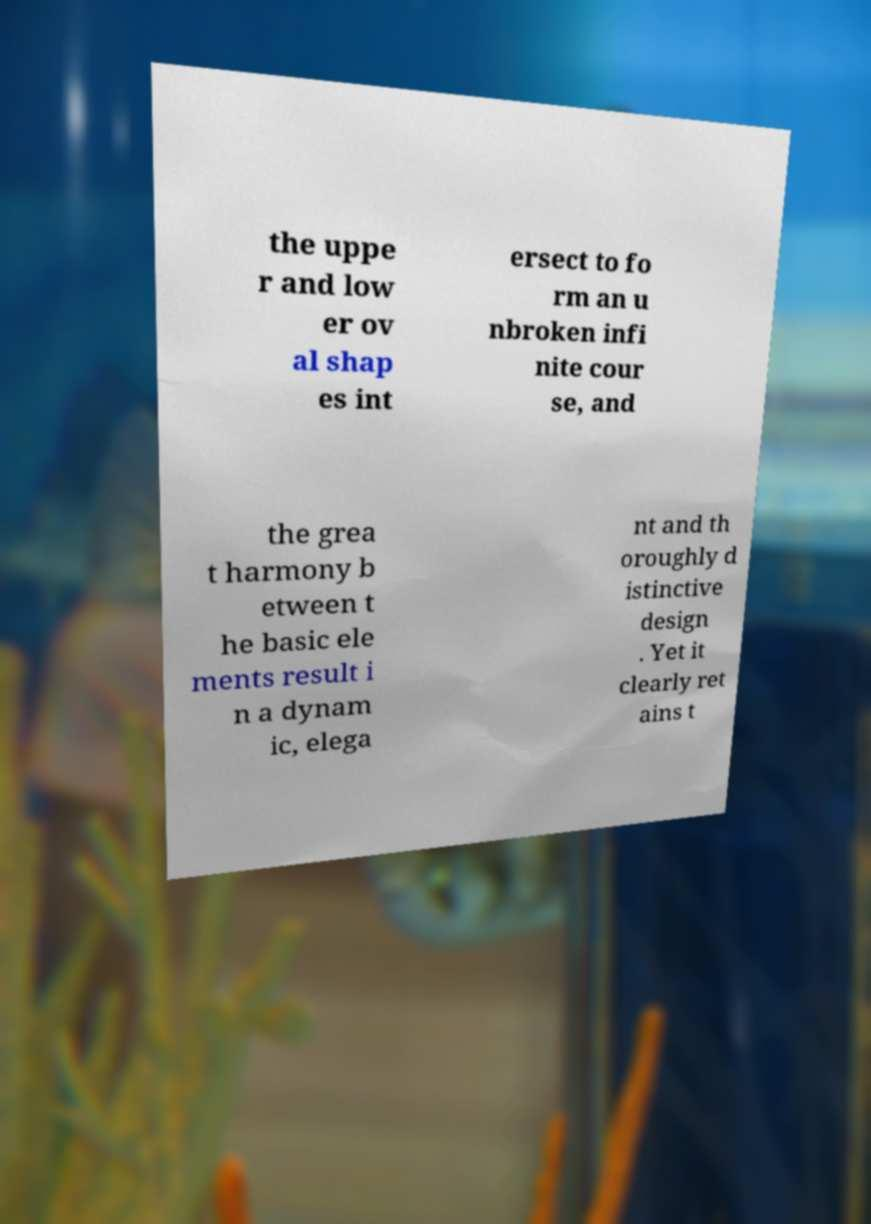For documentation purposes, I need the text within this image transcribed. Could you provide that? the uppe r and low er ov al shap es int ersect to fo rm an u nbroken infi nite cour se, and the grea t harmony b etween t he basic ele ments result i n a dynam ic, elega nt and th oroughly d istinctive design . Yet it clearly ret ains t 